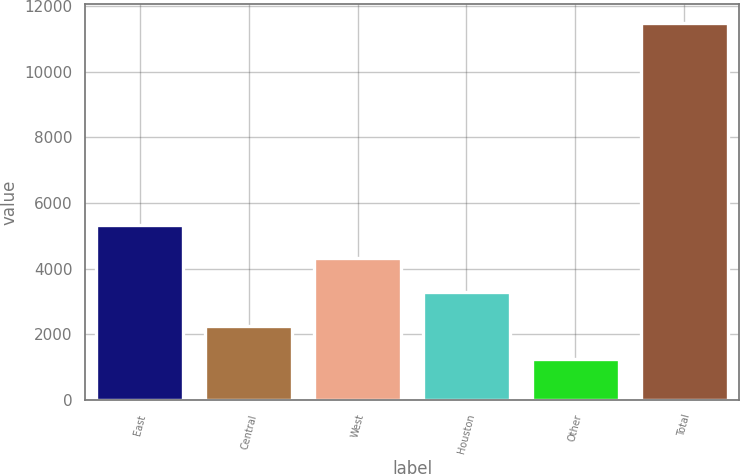<chart> <loc_0><loc_0><loc_500><loc_500><bar_chart><fcel>East<fcel>Central<fcel>West<fcel>Houston<fcel>Other<fcel>Total<nl><fcel>5332.2<fcel>2259.3<fcel>4307.9<fcel>3283.6<fcel>1235<fcel>11478<nl></chart> 